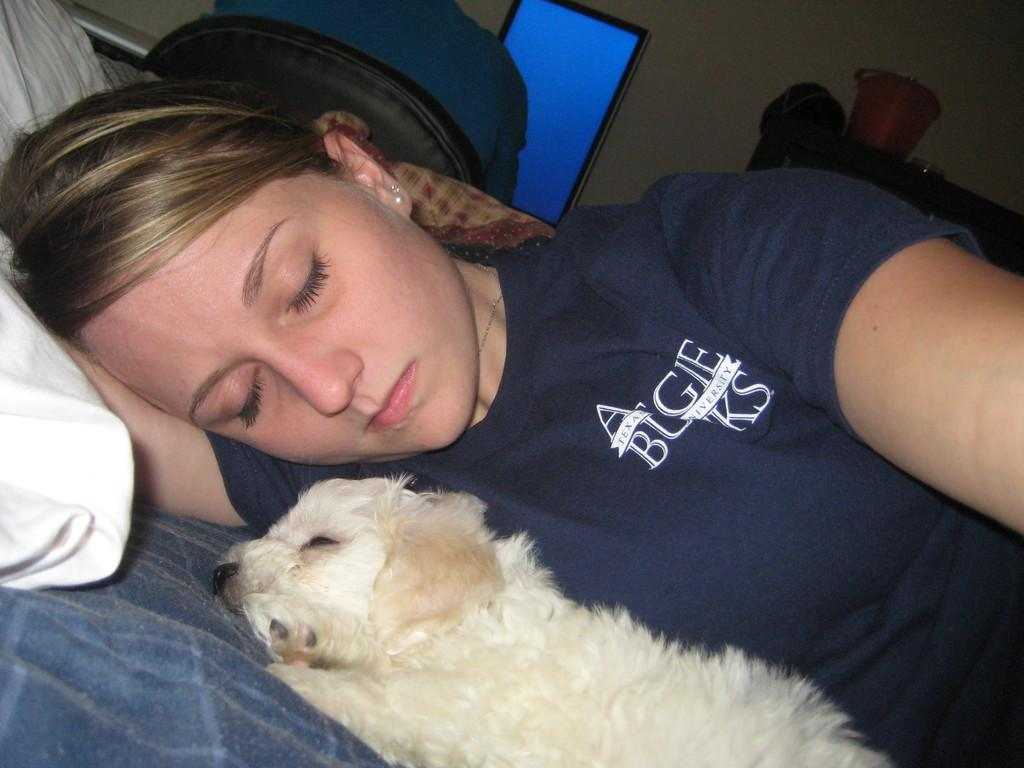Who is present in the image? There is a woman and a dog in the image. What is the woman doing in the image? The woman is sleeping. What is the dog doing in the image? The dog is sleeping. What type of toys can be seen in the image? There are no toys present in the image. What kind of minister is depicted in the image? There is no minister present in the image. 